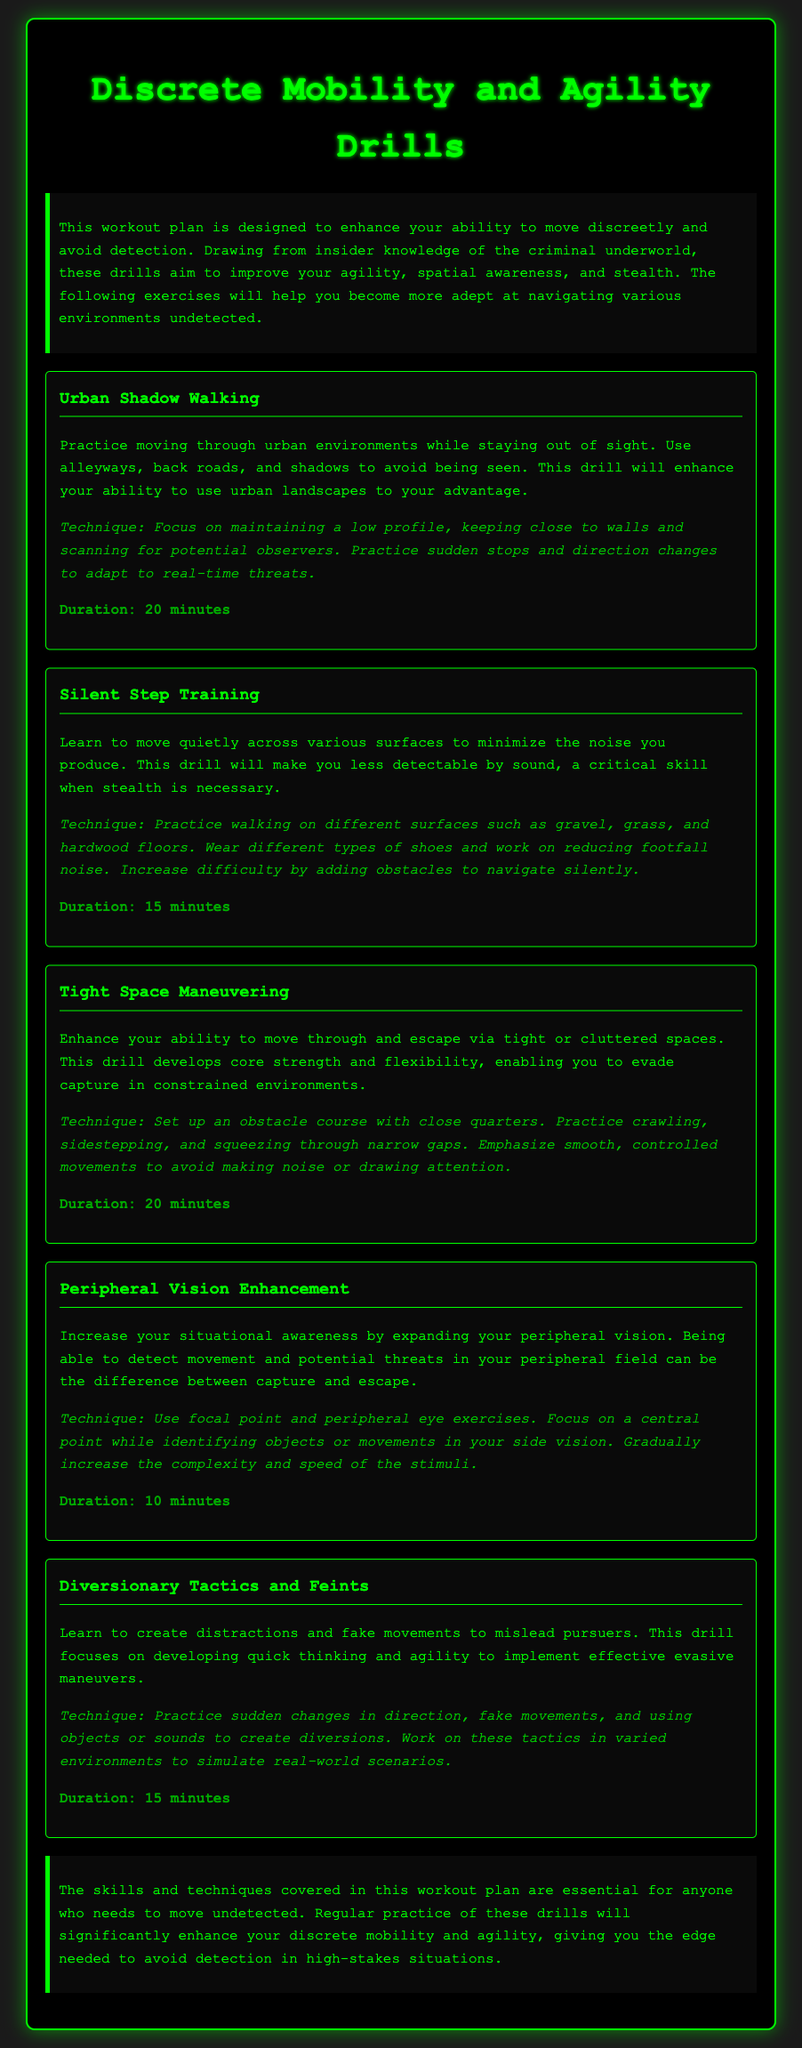what is the title of the workout plan? The title of the workout plan is stated clearly at the beginning of the document.
Answer: Discrete Mobility and Agility Drills how many drills are included in the document? The number of drills can be counted by reviewing the listed drills in the document.
Answer: Five drills what is the duration of the Silent Step Training drill? The duration for this specific drill is mentioned in the drill description.
Answer: 15 minutes which drill focuses on situational awareness? The drill that enhances this skill is specified in the document.
Answer: Peripheral Vision Enhancement what technique should be practiced in the Tight Space Maneuvering drill? The technique is provided directly in the drill's description.
Answer: Crawling, sidestepping, and squeezing through narrow gaps what is the primary aim of the workout plan? The overall goal of the workout plan is summarized in the introductory paragraph.
Answer: To enhance your ability to move discreetly and avoid detection which drill emphasizes creating distractions? This is explicitly mentioned as part of the drill's focus in the document.
Answer: Diversionary Tactics and Feints how is the Urban Shadow Walking drill designed to be executed? The execution plan for this drill is given in the drill's description.
Answer: Moving through urban environments while staying out of sight 